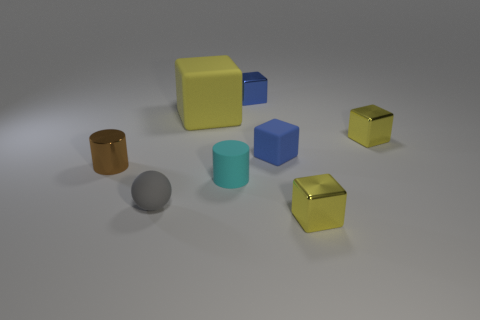What number of yellow things are large rubber cubes or small metal balls?
Give a very brief answer. 1. Does the cyan cylinder have the same material as the tiny cylinder that is to the left of the gray object?
Offer a terse response. No. What size is the yellow rubber thing that is the same shape as the blue rubber thing?
Provide a short and direct response. Large. What is the material of the tiny brown cylinder?
Your response must be concise. Metal. What is the large yellow thing that is behind the small cylinder in front of the brown thing that is on the left side of the tiny cyan matte object made of?
Provide a short and direct response. Rubber. There is a yellow metallic cube in front of the small rubber cylinder; is its size the same as the yellow object that is to the left of the matte cylinder?
Your answer should be very brief. No. What number of other things are the same material as the big yellow block?
Give a very brief answer. 3. How many matte objects are small yellow blocks or cylinders?
Offer a very short reply. 1. Are there fewer gray objects than big gray metal cylinders?
Give a very brief answer. No. There is a matte cylinder; is it the same size as the yellow shiny cube that is behind the sphere?
Your answer should be very brief. Yes. 